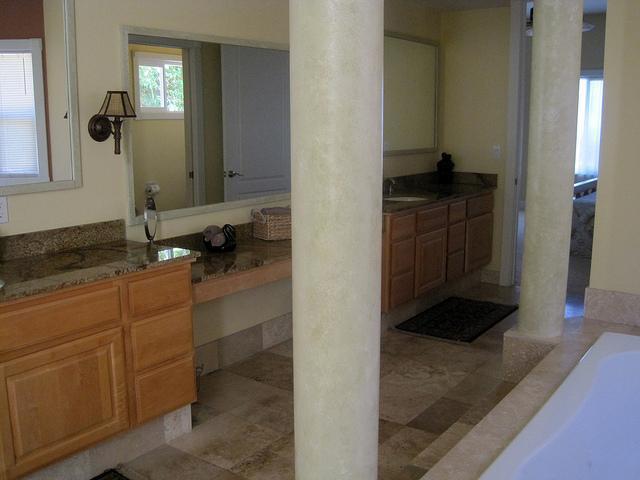How many windows are in the room?
Give a very brief answer. 2. How many pillars are there?
Give a very brief answer. 2. How many clocks are there?
Give a very brief answer. 0. 